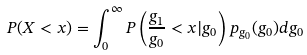Convert formula to latex. <formula><loc_0><loc_0><loc_500><loc_500>P ( X < x ) = \int ^ { \infty } _ { 0 } P \left ( \frac { g _ { 1 } } { g _ { 0 } } < x | g _ { 0 } \right ) p _ { g _ { 0 } } ( g _ { 0 } ) d g _ { 0 }</formula> 